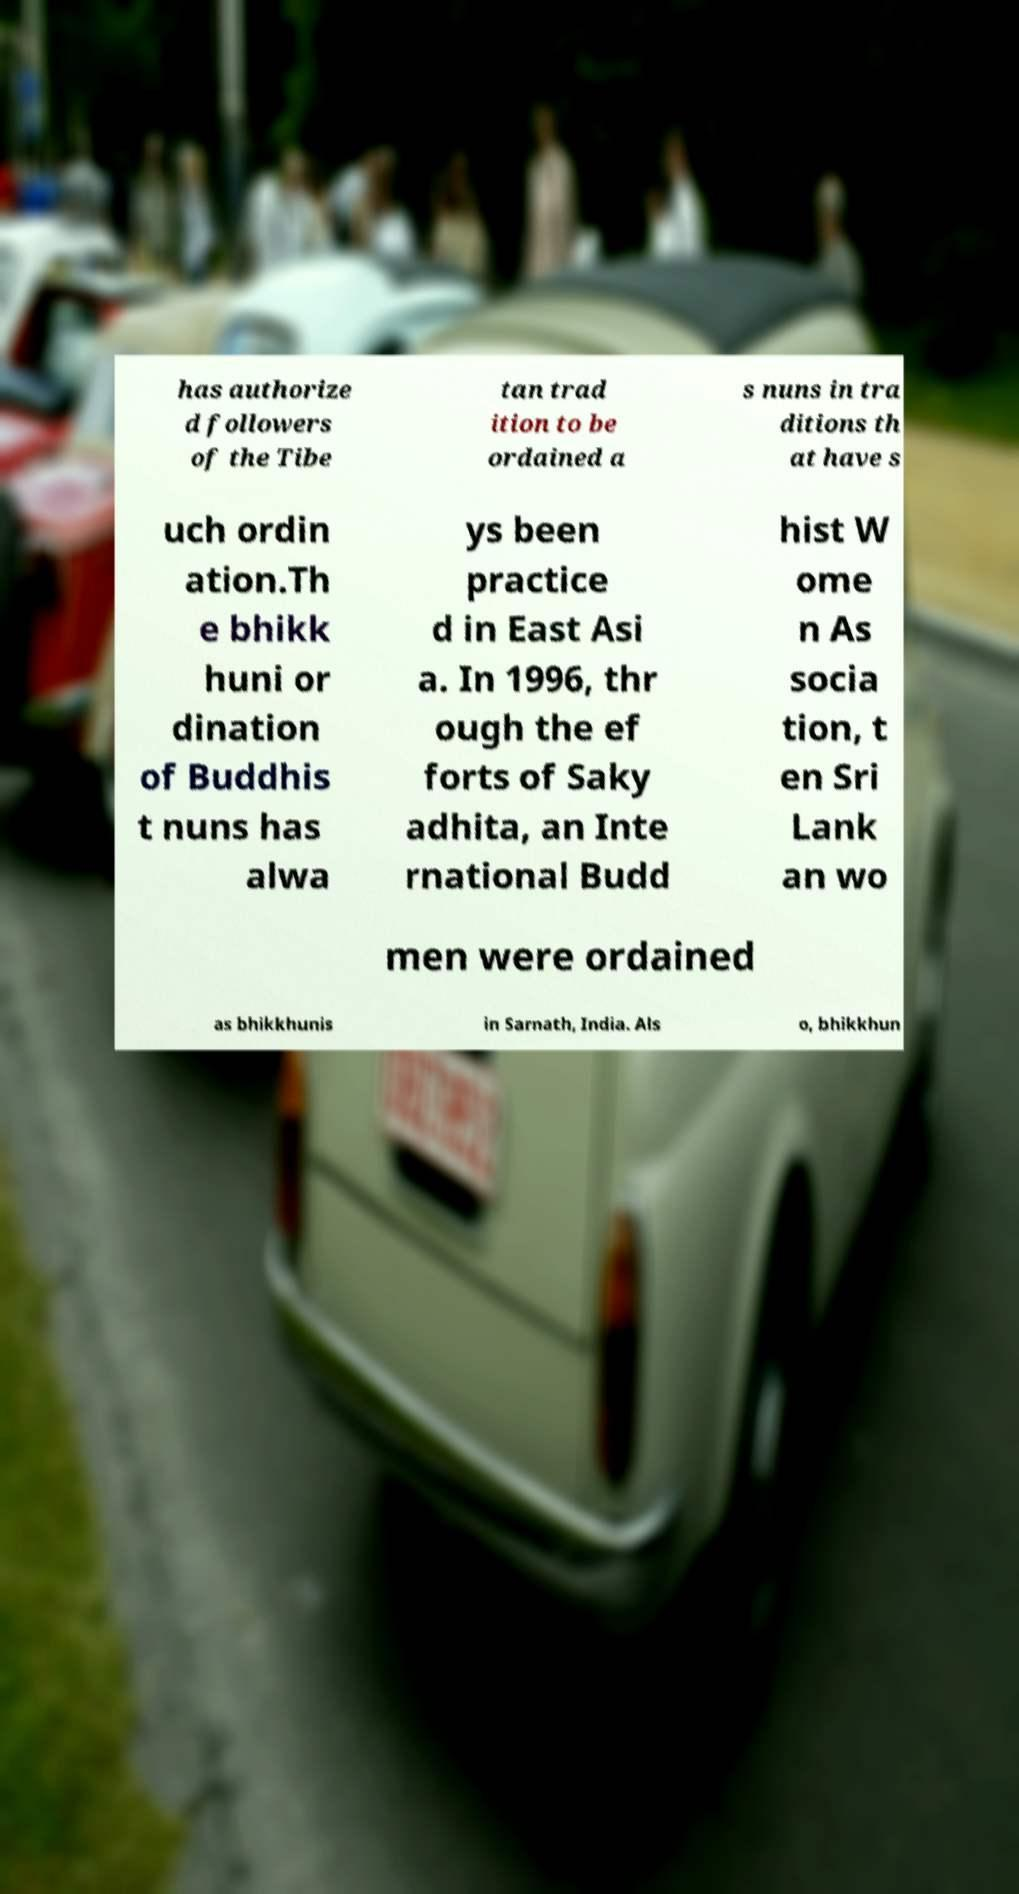Please read and relay the text visible in this image. What does it say? has authorize d followers of the Tibe tan trad ition to be ordained a s nuns in tra ditions th at have s uch ordin ation.Th e bhikk huni or dination of Buddhis t nuns has alwa ys been practice d in East Asi a. In 1996, thr ough the ef forts of Saky adhita, an Inte rnational Budd hist W ome n As socia tion, t en Sri Lank an wo men were ordained as bhikkhunis in Sarnath, India. Als o, bhikkhun 